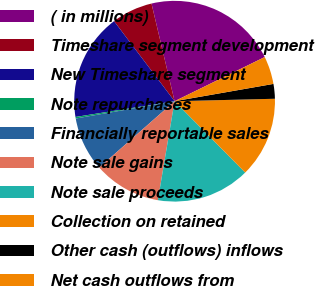<chart> <loc_0><loc_0><loc_500><loc_500><pie_chart><fcel>( in millions)<fcel>Timeshare segment development<fcel>New Timeshare segment<fcel>Note repurchases<fcel>Financially reportable sales<fcel>Note sale gains<fcel>Note sale proceeds<fcel>Collection on retained<fcel>Other cash (outflows) inflows<fcel>Net cash outflows from<nl><fcel>21.45%<fcel>6.61%<fcel>17.21%<fcel>0.25%<fcel>8.73%<fcel>10.85%<fcel>15.09%<fcel>12.97%<fcel>2.37%<fcel>4.49%<nl></chart> 